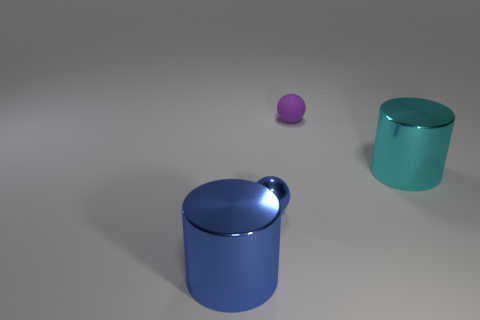Add 3 tiny red matte things. How many objects exist? 7 Add 1 blue spheres. How many blue spheres exist? 2 Subtract 0 cyan cubes. How many objects are left? 4 Subtract all cyan blocks. Subtract all small metallic spheres. How many objects are left? 3 Add 1 tiny rubber spheres. How many tiny rubber spheres are left? 2 